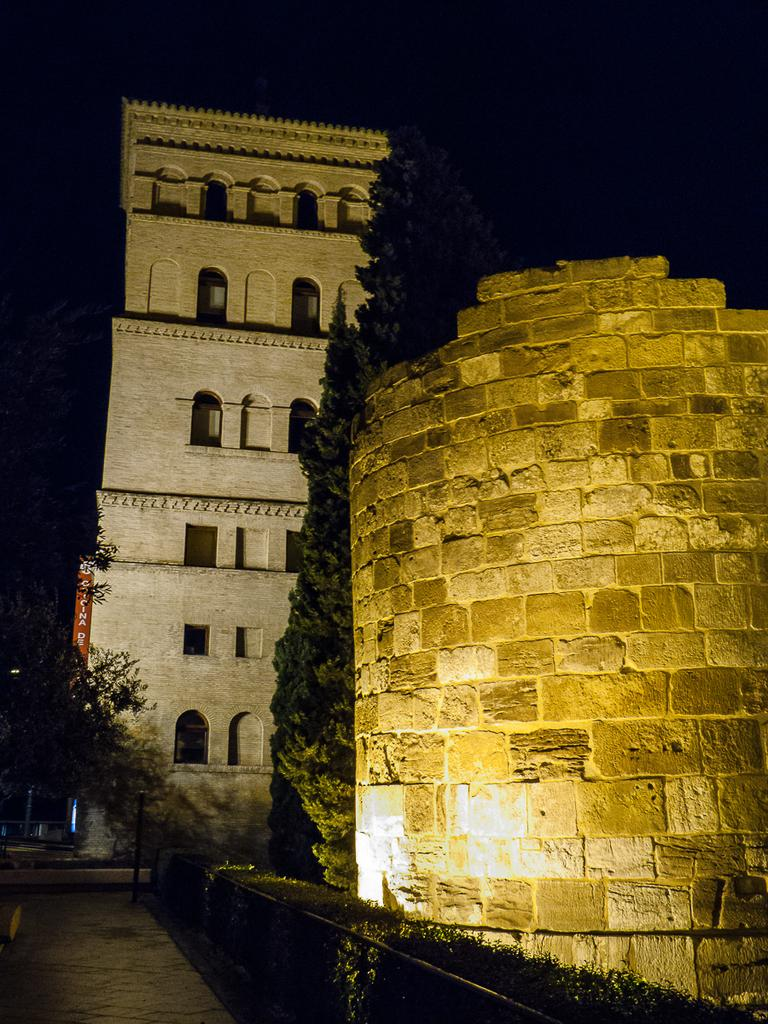What type of structures can be seen in the image? There are buildings in the image. What other natural or man-made elements can be seen in the image? There are trees, a pavement, a metal fence, and bushes visible in the image. How are the buildings and natural elements arranged in the image? The buildings are in front of the trees, and there is a pavement in front of the buildings. A metal fence is beside the pavement, and bushes are beside the metal fence. Who is the creator of the baby in the image? There is no baby present in the image, so it is not possible to determine the creator. 